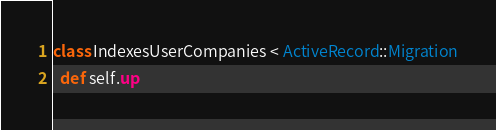<code> <loc_0><loc_0><loc_500><loc_500><_Ruby_>class IndexesUserCompanies < ActiveRecord::Migration
  def self.up</code> 